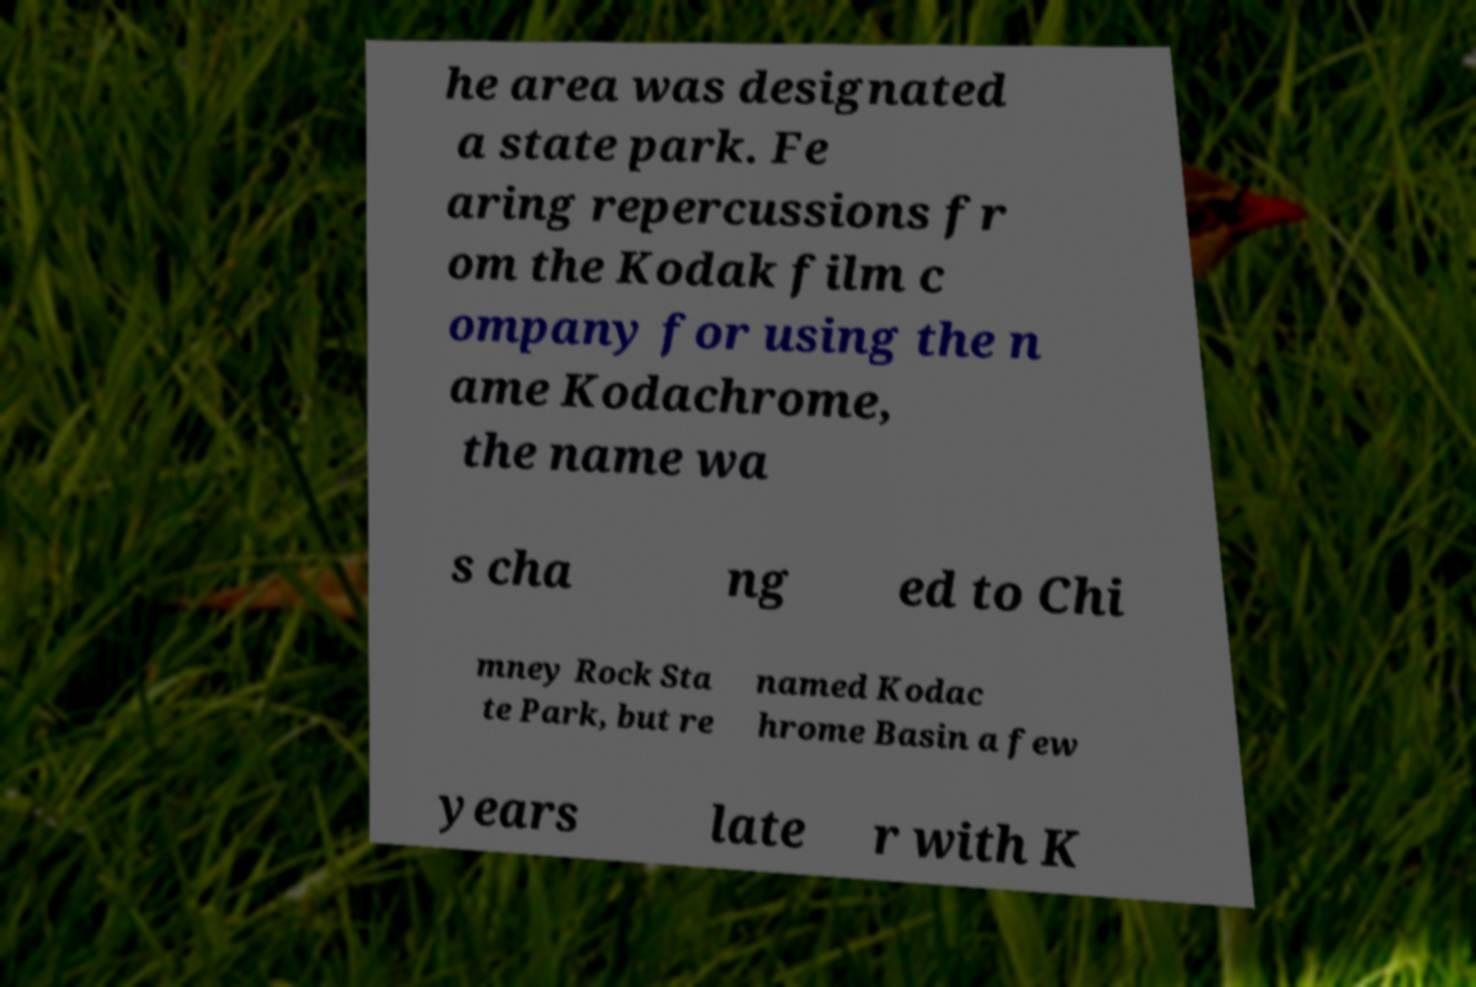What messages or text are displayed in this image? I need them in a readable, typed format. he area was designated a state park. Fe aring repercussions fr om the Kodak film c ompany for using the n ame Kodachrome, the name wa s cha ng ed to Chi mney Rock Sta te Park, but re named Kodac hrome Basin a few years late r with K 